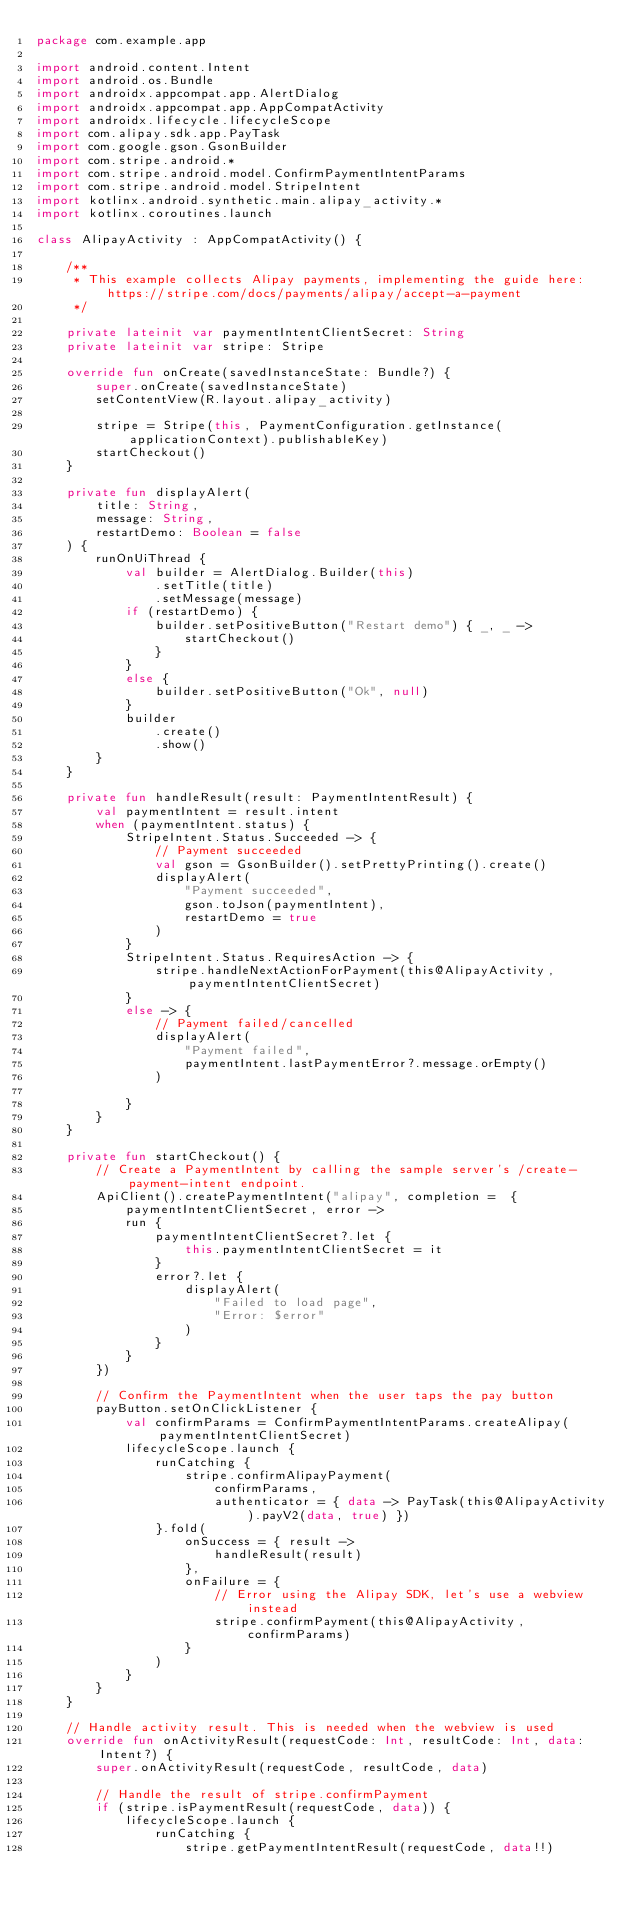Convert code to text. <code><loc_0><loc_0><loc_500><loc_500><_Kotlin_>package com.example.app

import android.content.Intent
import android.os.Bundle
import androidx.appcompat.app.AlertDialog
import androidx.appcompat.app.AppCompatActivity
import androidx.lifecycle.lifecycleScope
import com.alipay.sdk.app.PayTask
import com.google.gson.GsonBuilder
import com.stripe.android.*
import com.stripe.android.model.ConfirmPaymentIntentParams
import com.stripe.android.model.StripeIntent
import kotlinx.android.synthetic.main.alipay_activity.*
import kotlinx.coroutines.launch

class AlipayActivity : AppCompatActivity() {

    /**
     * This example collects Alipay payments, implementing the guide here: https://stripe.com/docs/payments/alipay/accept-a-payment
     */

    private lateinit var paymentIntentClientSecret: String
    private lateinit var stripe: Stripe

    override fun onCreate(savedInstanceState: Bundle?) {
        super.onCreate(savedInstanceState)
        setContentView(R.layout.alipay_activity)

        stripe = Stripe(this, PaymentConfiguration.getInstance(applicationContext).publishableKey)
        startCheckout()
    }

    private fun displayAlert(
        title: String,
        message: String,
        restartDemo: Boolean = false
    ) {
        runOnUiThread {
            val builder = AlertDialog.Builder(this)
                .setTitle(title)
                .setMessage(message)
            if (restartDemo) {
                builder.setPositiveButton("Restart demo") { _, _ ->
                    startCheckout()
                }
            }
            else {
                builder.setPositiveButton("Ok", null)
            }
            builder
                .create()
                .show()
        }
    }

    private fun handleResult(result: PaymentIntentResult) {
        val paymentIntent = result.intent
        when (paymentIntent.status) {
            StripeIntent.Status.Succeeded -> {
                // Payment succeeded
                val gson = GsonBuilder().setPrettyPrinting().create()
                displayAlert(
                    "Payment succeeded",
                    gson.toJson(paymentIntent),
                    restartDemo = true
                )
            }
            StripeIntent.Status.RequiresAction -> {
                stripe.handleNextActionForPayment(this@AlipayActivity, paymentIntentClientSecret)
            }
            else -> {
                // Payment failed/cancelled
                displayAlert(
                    "Payment failed",
                    paymentIntent.lastPaymentError?.message.orEmpty()
                )

            }
        }
    }

    private fun startCheckout() {
        // Create a PaymentIntent by calling the sample server's /create-payment-intent endpoint.
        ApiClient().createPaymentIntent("alipay", completion =  {
            paymentIntentClientSecret, error ->
            run {
                paymentIntentClientSecret?.let {
                    this.paymentIntentClientSecret = it
                }
                error?.let {
                    displayAlert(
                        "Failed to load page",
                        "Error: $error"
                    )
                }
            }
        })

        // Confirm the PaymentIntent when the user taps the pay button
        payButton.setOnClickListener {
            val confirmParams = ConfirmPaymentIntentParams.createAlipay(paymentIntentClientSecret)
            lifecycleScope.launch {
                runCatching {
                    stripe.confirmAlipayPayment(
                        confirmParams,
                        authenticator = { data -> PayTask(this@AlipayActivity).payV2(data, true) })
                }.fold(
                    onSuccess = { result ->
                        handleResult(result)
                    },
                    onFailure = {
                        // Error using the Alipay SDK, let's use a webview instead
                        stripe.confirmPayment(this@AlipayActivity, confirmParams)
                    }
                )
            }
        }
    }

    // Handle activity result. This is needed when the webview is used
    override fun onActivityResult(requestCode: Int, resultCode: Int, data: Intent?) {
        super.onActivityResult(requestCode, resultCode, data)

        // Handle the result of stripe.confirmPayment
        if (stripe.isPaymentResult(requestCode, data)) {
            lifecycleScope.launch {
                runCatching {
                    stripe.getPaymentIntentResult(requestCode, data!!)</code> 